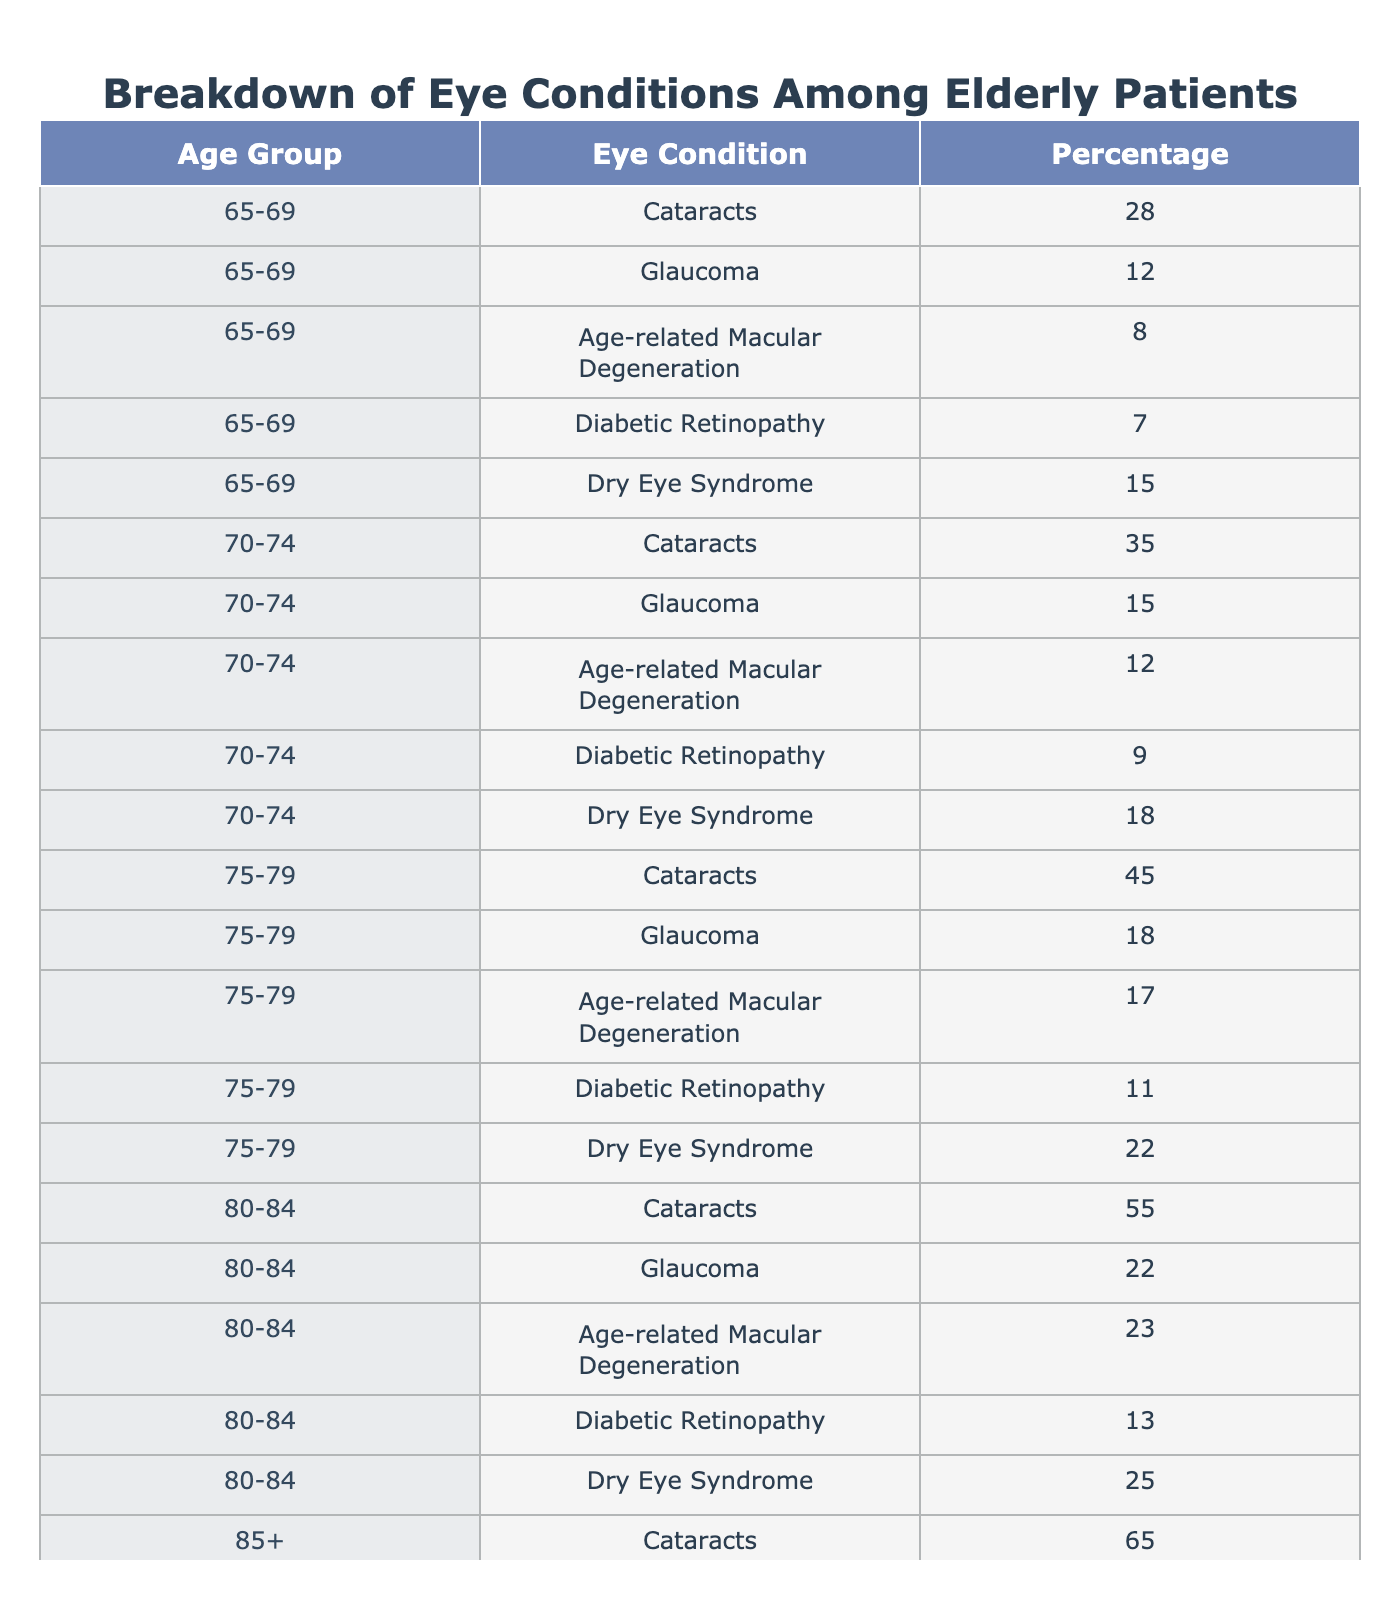What percentage of patients in the 80-84 age group have Cataracts? In the table, for the age group 80-84, the percentage listed for Cataracts is 55.
Answer: 55% Which eye condition has the highest percentage in the 75-79 age group? Looking at the 75-79 age group, Cataracts has the highest percentage at 45, compared to other conditions listed.
Answer: Cataracts Which age group has the lowest percentage of Glaucoma? By reviewing the table, the 65-69 age group has the lowest percentage of Glaucoma at 12 compared to older age groups.
Answer: 65-69 What percentage of patients aged 85 and older suffer from Age-related Macular Degeneration? In the table, the entry for the 85+ age group shows that 30% of patients have Age-related Macular Degeneration.
Answer: 30% Calculate the total percentage of Dry Eye Syndrome across all age groups. Adding up the percentages from the table: 15 + 18 + 22 + 25 + 30 = 110.
Answer: 110% Is Glaucoma more prevalent among patients aged 80-84 compared to those aged 75-79? For the 80-84 age group, Glaucoma is at 22%, while for the 75-79 age group, it is at 18%. Thus, Glaucoma is more prevalent in the 80-84 age group (22% > 18%).
Answer: Yes What is the average percentage of Cataracts across all age groups? The percentages for Cataracts are 28, 35, 45, 55, and 65. Adding them gives 228, and dividing by 5 (the number of age groups), we get 45.6.
Answer: 45.6% Which eye condition appears most frequently across all age groups? Reviewing the table, Cataracts has the highest percentages in every age group, indicating it appears most frequently.
Answer: Cataracts How does the percentage of Diabetic Retinopathy change from the 70-74 to the 85+ age groups? For the 70-74 age group, the percentage of Diabetic Retinopathy is 9%, while for the 85+ age group, it is 15%, indicating an increase of 6%.
Answer: Increase of 6% Which age group has the largest percentage of Dry Eye Syndrome? The largest percentage for Dry Eye Syndrome is in the 85+ age group at 30%, which is higher than any other age group listed.
Answer: 85+ 